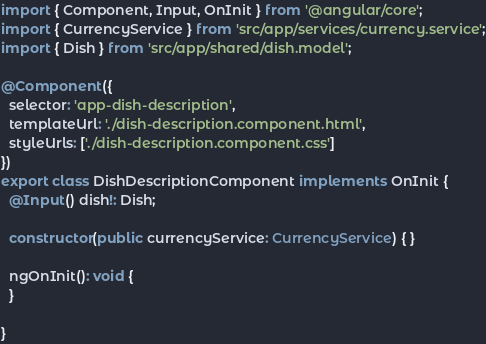Convert code to text. <code><loc_0><loc_0><loc_500><loc_500><_TypeScript_>import { Component, Input, OnInit } from '@angular/core';
import { CurrencyService } from 'src/app/services/currency.service';
import { Dish } from 'src/app/shared/dish.model';

@Component({
  selector: 'app-dish-description',
  templateUrl: './dish-description.component.html',
  styleUrls: ['./dish-description.component.css']
})
export class DishDescriptionComponent implements OnInit {
  @Input() dish!: Dish;

  constructor(public currencyService: CurrencyService) { }

  ngOnInit(): void {
  }

}
</code> 